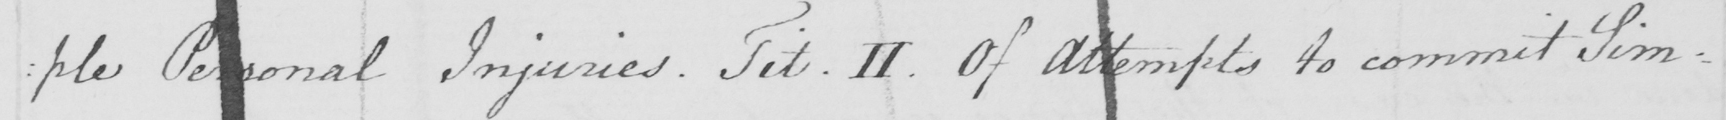What does this handwritten line say? : ple Personal Injuries . Tit . II . Of Attempts to commit Sim= 